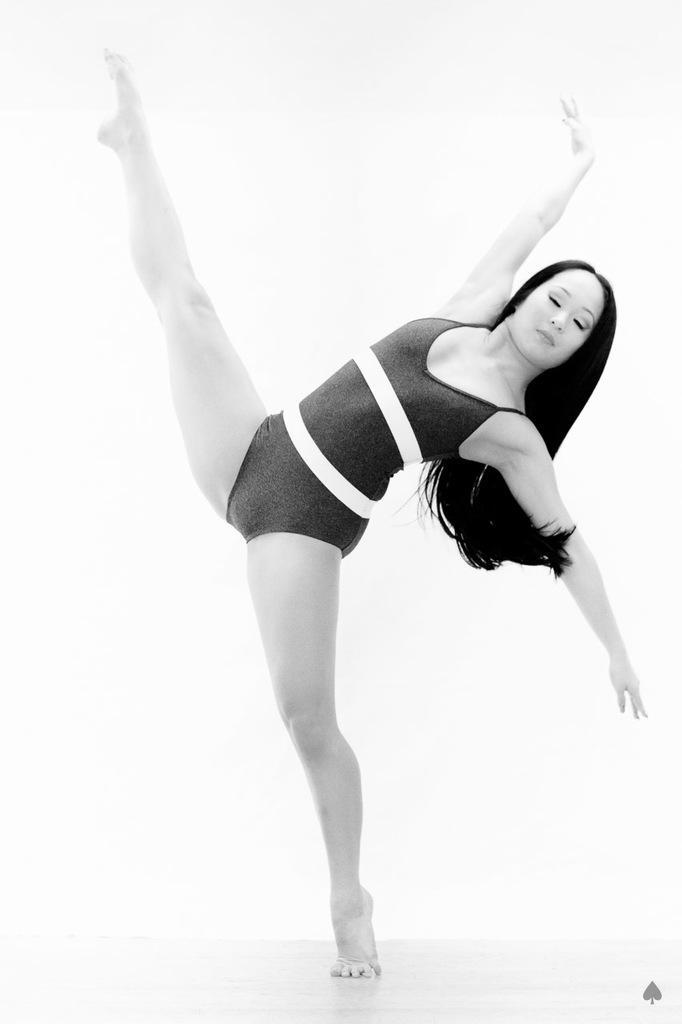Describe this image in one or two sentences. This image is a black and white image. At the bottom of the image there is a floor. In the middle of the image a woman is dancing on the floor. 